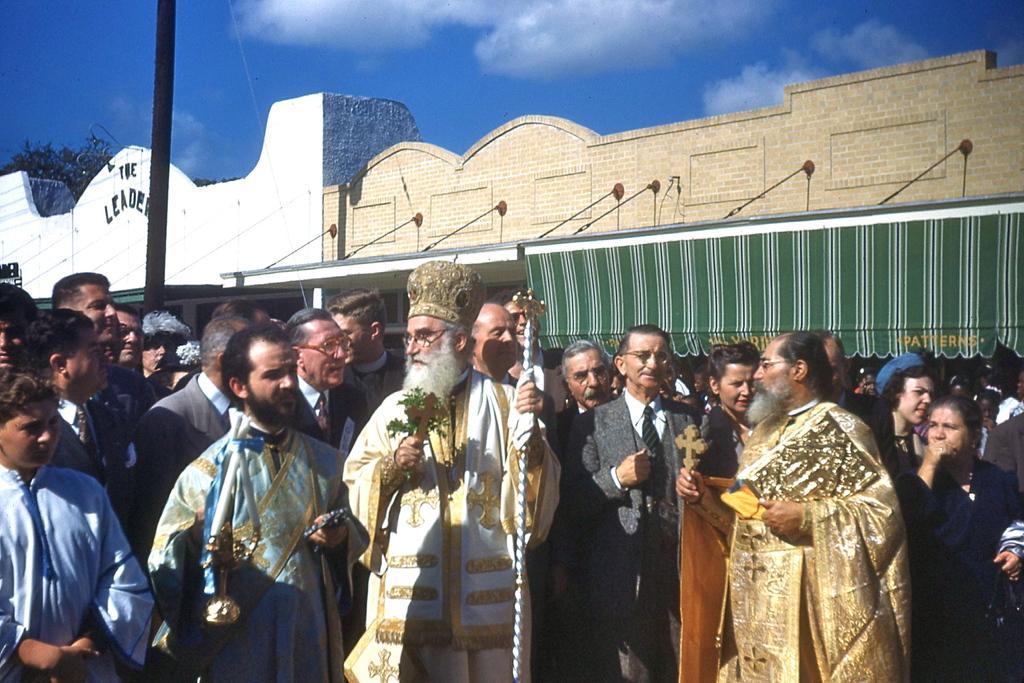Could you give a brief overview of what you see in this image? This picture shows few people standing. We see a man wore a cap on his head and leaves in other hand and we see a building and a tree and we see a blue cloudy sky and a pole and another man holding a cross in his hand. 